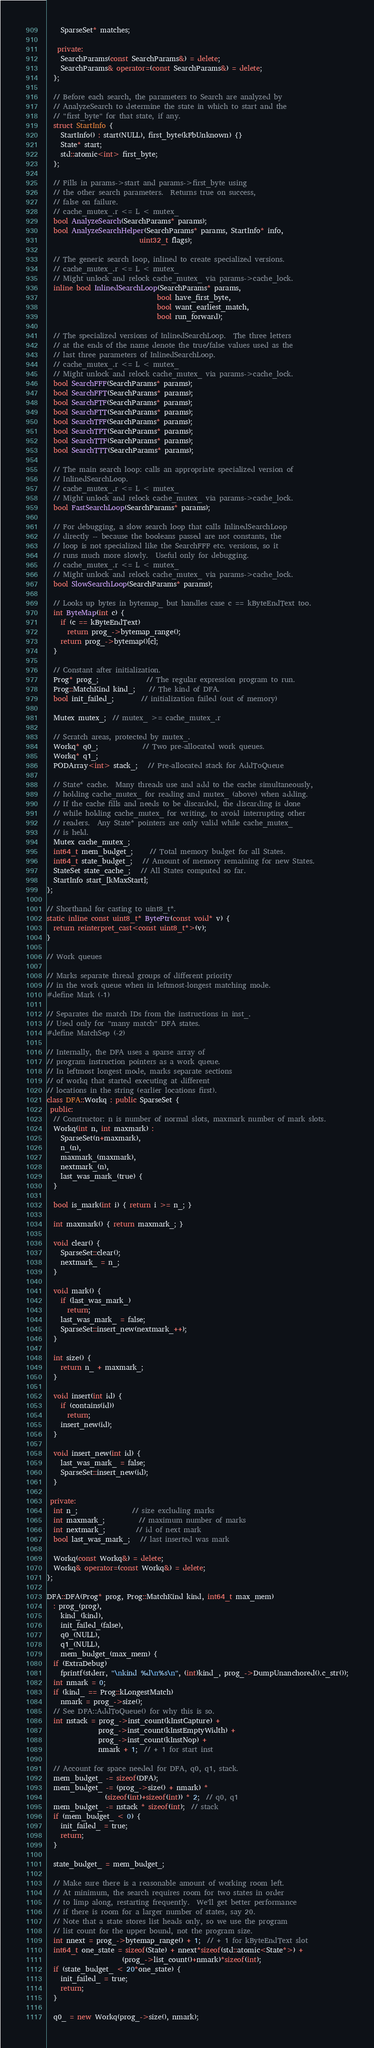Convert code to text. <code><loc_0><loc_0><loc_500><loc_500><_C++_>    SparseSet* matches;

   private:
    SearchParams(const SearchParams&) = delete;
    SearchParams& operator=(const SearchParams&) = delete;
  };

  // Before each search, the parameters to Search are analyzed by
  // AnalyzeSearch to determine the state in which to start and the
  // "first_byte" for that state, if any.
  struct StartInfo {
    StartInfo() : start(NULL), first_byte(kFbUnknown) {}
    State* start;
    std::atomic<int> first_byte;
  };

  // Fills in params->start and params->first_byte using
  // the other search parameters.  Returns true on success,
  // false on failure.
  // cache_mutex_.r <= L < mutex_
  bool AnalyzeSearch(SearchParams* params);
  bool AnalyzeSearchHelper(SearchParams* params, StartInfo* info,
                           uint32_t flags);

  // The generic search loop, inlined to create specialized versions.
  // cache_mutex_.r <= L < mutex_
  // Might unlock and relock cache_mutex_ via params->cache_lock.
  inline bool InlinedSearchLoop(SearchParams* params,
                                bool have_first_byte,
                                bool want_earliest_match,
                                bool run_forward);

  // The specialized versions of InlinedSearchLoop.  The three letters
  // at the ends of the name denote the true/false values used as the
  // last three parameters of InlinedSearchLoop.
  // cache_mutex_.r <= L < mutex_
  // Might unlock and relock cache_mutex_ via params->cache_lock.
  bool SearchFFF(SearchParams* params);
  bool SearchFFT(SearchParams* params);
  bool SearchFTF(SearchParams* params);
  bool SearchFTT(SearchParams* params);
  bool SearchTFF(SearchParams* params);
  bool SearchTFT(SearchParams* params);
  bool SearchTTF(SearchParams* params);
  bool SearchTTT(SearchParams* params);

  // The main search loop: calls an appropriate specialized version of
  // InlinedSearchLoop.
  // cache_mutex_.r <= L < mutex_
  // Might unlock and relock cache_mutex_ via params->cache_lock.
  bool FastSearchLoop(SearchParams* params);

  // For debugging, a slow search loop that calls InlinedSearchLoop
  // directly -- because the booleans passed are not constants, the
  // loop is not specialized like the SearchFFF etc. versions, so it
  // runs much more slowly.  Useful only for debugging.
  // cache_mutex_.r <= L < mutex_
  // Might unlock and relock cache_mutex_ via params->cache_lock.
  bool SlowSearchLoop(SearchParams* params);

  // Looks up bytes in bytemap_ but handles case c == kByteEndText too.
  int ByteMap(int c) {
    if (c == kByteEndText)
      return prog_->bytemap_range();
    return prog_->bytemap()[c];
  }

  // Constant after initialization.
  Prog* prog_;              // The regular expression program to run.
  Prog::MatchKind kind_;    // The kind of DFA.
  bool init_failed_;        // initialization failed (out of memory)

  Mutex mutex_;  // mutex_ >= cache_mutex_.r

  // Scratch areas, protected by mutex_.
  Workq* q0_;             // Two pre-allocated work queues.
  Workq* q1_;
  PODArray<int> stack_;   // Pre-allocated stack for AddToQueue

  // State* cache.  Many threads use and add to the cache simultaneously,
  // holding cache_mutex_ for reading and mutex_ (above) when adding.
  // If the cache fills and needs to be discarded, the discarding is done
  // while holding cache_mutex_ for writing, to avoid interrupting other
  // readers.  Any State* pointers are only valid while cache_mutex_
  // is held.
  Mutex cache_mutex_;
  int64_t mem_budget_;     // Total memory budget for all States.
  int64_t state_budget_;   // Amount of memory remaining for new States.
  StateSet state_cache_;   // All States computed so far.
  StartInfo start_[kMaxStart];
};

// Shorthand for casting to uint8_t*.
static inline const uint8_t* BytePtr(const void* v) {
  return reinterpret_cast<const uint8_t*>(v);
}

// Work queues

// Marks separate thread groups of different priority
// in the work queue when in leftmost-longest matching mode.
#define Mark (-1)

// Separates the match IDs from the instructions in inst_.
// Used only for "many match" DFA states.
#define MatchSep (-2)

// Internally, the DFA uses a sparse array of
// program instruction pointers as a work queue.
// In leftmost longest mode, marks separate sections
// of workq that started executing at different
// locations in the string (earlier locations first).
class DFA::Workq : public SparseSet {
 public:
  // Constructor: n is number of normal slots, maxmark number of mark slots.
  Workq(int n, int maxmark) :
    SparseSet(n+maxmark),
    n_(n),
    maxmark_(maxmark),
    nextmark_(n),
    last_was_mark_(true) {
  }

  bool is_mark(int i) { return i >= n_; }

  int maxmark() { return maxmark_; }

  void clear() {
    SparseSet::clear();
    nextmark_ = n_;
  }

  void mark() {
    if (last_was_mark_)
      return;
    last_was_mark_ = false;
    SparseSet::insert_new(nextmark_++);
  }

  int size() {
    return n_ + maxmark_;
  }

  void insert(int id) {
    if (contains(id))
      return;
    insert_new(id);
  }

  void insert_new(int id) {
    last_was_mark_ = false;
    SparseSet::insert_new(id);
  }

 private:
  int n_;                // size excluding marks
  int maxmark_;          // maximum number of marks
  int nextmark_;         // id of next mark
  bool last_was_mark_;   // last inserted was mark

  Workq(const Workq&) = delete;
  Workq& operator=(const Workq&) = delete;
};

DFA::DFA(Prog* prog, Prog::MatchKind kind, int64_t max_mem)
  : prog_(prog),
    kind_(kind),
    init_failed_(false),
    q0_(NULL),
    q1_(NULL),
    mem_budget_(max_mem) {
  if (ExtraDebug)
    fprintf(stderr, "\nkind %d\n%s\n", (int)kind_, prog_->DumpUnanchored().c_str());
  int nmark = 0;
  if (kind_ == Prog::kLongestMatch)
    nmark = prog_->size();
  // See DFA::AddToQueue() for why this is so.
  int nstack = prog_->inst_count(kInstCapture) +
               prog_->inst_count(kInstEmptyWidth) +
               prog_->inst_count(kInstNop) +
               nmark + 1;  // + 1 for start inst

  // Account for space needed for DFA, q0, q1, stack.
  mem_budget_ -= sizeof(DFA);
  mem_budget_ -= (prog_->size() + nmark) *
                 (sizeof(int)+sizeof(int)) * 2;  // q0, q1
  mem_budget_ -= nstack * sizeof(int);  // stack
  if (mem_budget_ < 0) {
    init_failed_ = true;
    return;
  }

  state_budget_ = mem_budget_;

  // Make sure there is a reasonable amount of working room left.
  // At minimum, the search requires room for two states in order
  // to limp along, restarting frequently.  We'll get better performance
  // if there is room for a larger number of states, say 20.
  // Note that a state stores list heads only, so we use the program
  // list count for the upper bound, not the program size.
  int nnext = prog_->bytemap_range() + 1;  // + 1 for kByteEndText slot
  int64_t one_state = sizeof(State) + nnext*sizeof(std::atomic<State*>) +
                      (prog_->list_count()+nmark)*sizeof(int);
  if (state_budget_ < 20*one_state) {
    init_failed_ = true;
    return;
  }

  q0_ = new Workq(prog_->size(), nmark);</code> 